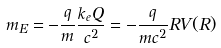<formula> <loc_0><loc_0><loc_500><loc_500>m _ { E } = - \frac { q } { m } \frac { k _ { e } Q } { c ^ { 2 } } = - \frac { q } { m c ^ { 2 } } R V ( R )</formula> 